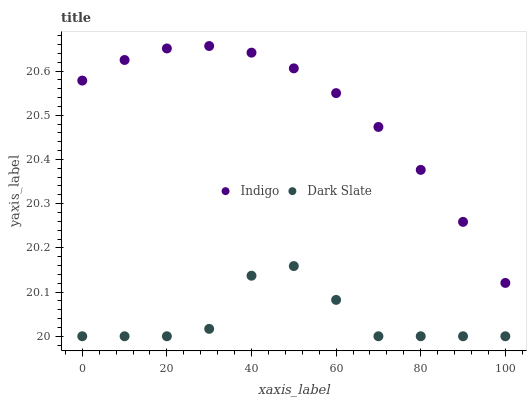Does Dark Slate have the minimum area under the curve?
Answer yes or no. Yes. Does Indigo have the maximum area under the curve?
Answer yes or no. Yes. Does Indigo have the minimum area under the curve?
Answer yes or no. No. Is Indigo the smoothest?
Answer yes or no. Yes. Is Dark Slate the roughest?
Answer yes or no. Yes. Is Indigo the roughest?
Answer yes or no. No. Does Dark Slate have the lowest value?
Answer yes or no. Yes. Does Indigo have the lowest value?
Answer yes or no. No. Does Indigo have the highest value?
Answer yes or no. Yes. Is Dark Slate less than Indigo?
Answer yes or no. Yes. Is Indigo greater than Dark Slate?
Answer yes or no. Yes. Does Dark Slate intersect Indigo?
Answer yes or no. No. 